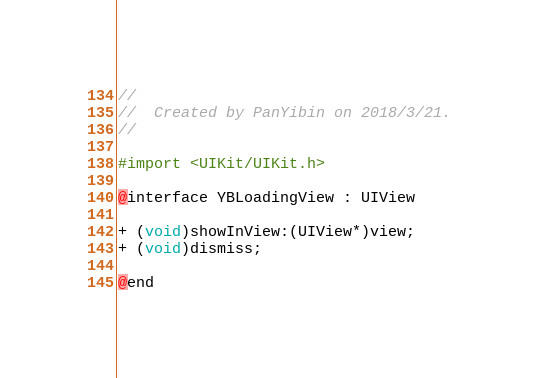Convert code to text. <code><loc_0><loc_0><loc_500><loc_500><_C_>//
//  Created by PanYibin on 2018/3/21.
//

#import <UIKit/UIKit.h>

@interface YBLoadingView : UIView

+ (void)showInView:(UIView*)view;
+ (void)dismiss;

@end
</code> 